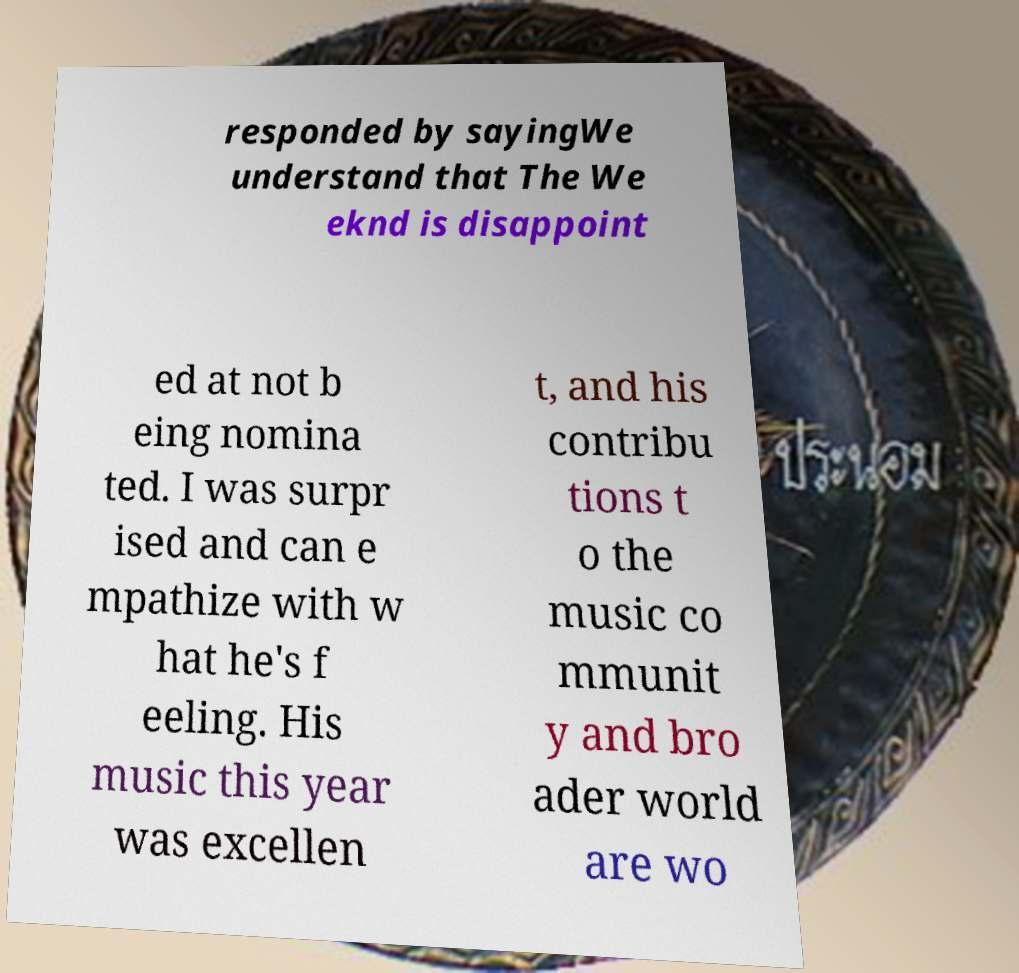There's text embedded in this image that I need extracted. Can you transcribe it verbatim? responded by sayingWe understand that The We eknd is disappoint ed at not b eing nomina ted. I was surpr ised and can e mpathize with w hat he's f eeling. His music this year was excellen t, and his contribu tions t o the music co mmunit y and bro ader world are wo 